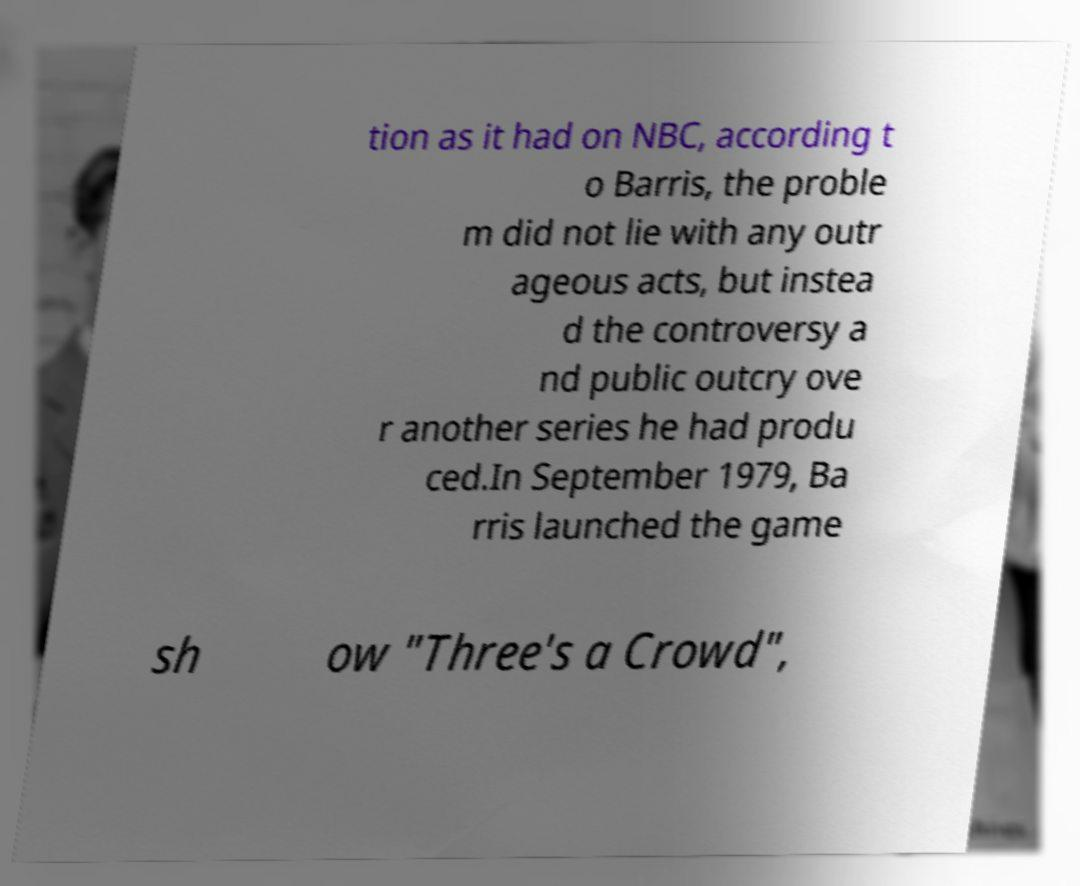Can you accurately transcribe the text from the provided image for me? tion as it had on NBC, according t o Barris, the proble m did not lie with any outr ageous acts, but instea d the controversy a nd public outcry ove r another series he had produ ced.In September 1979, Ba rris launched the game sh ow "Three's a Crowd", 